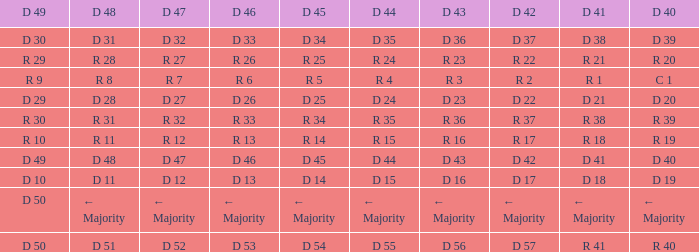I want the D 45 and D 42 of r 22 R 25. 